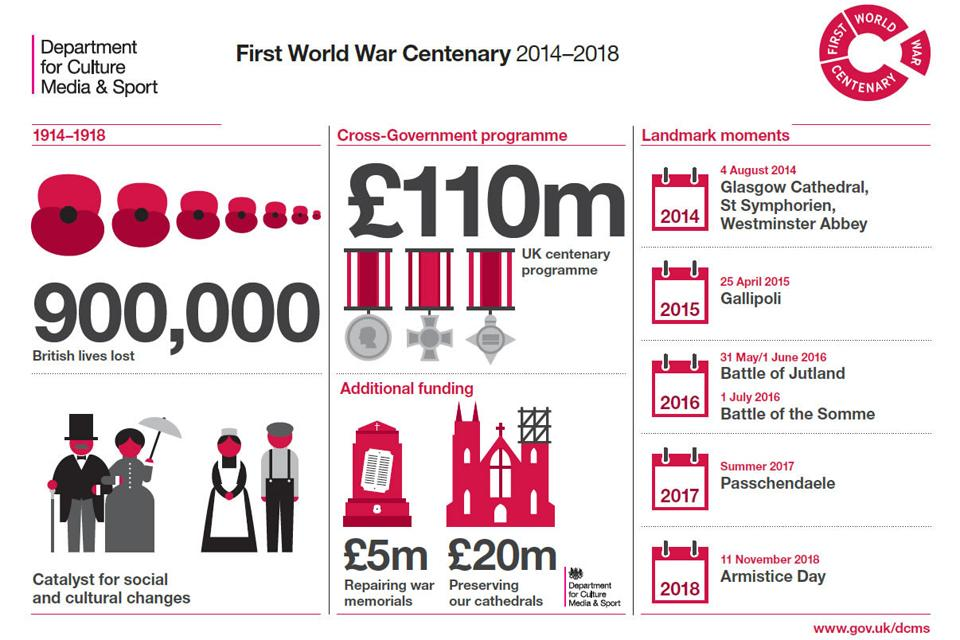Specify some key components in this picture. On November 11, 2018, a significant landmark moment occurred. It was Armistice Day, marking the end of the First World War. This date is now recognized worldwide as a day to honor and remember those who have served and sacrificed for their countries. The procurement of an additional funding of 5 million pounds was made for the purpose of repairing war memorials. 